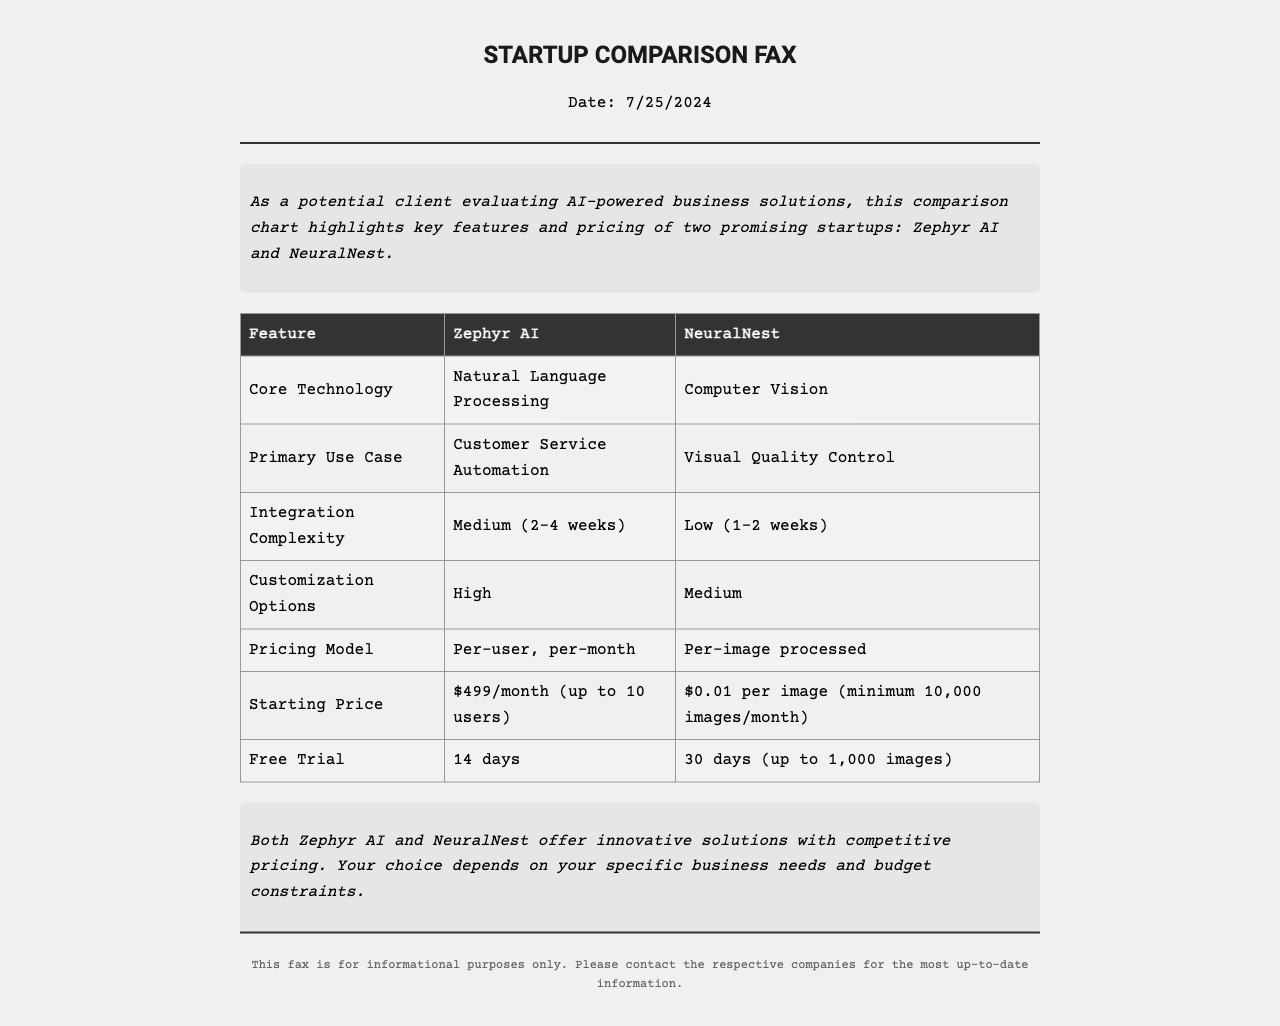What is the core technology used by Zephyr AI? The document states that the core technology for Zephyr AI is Natural Language Processing.
Answer: Natural Language Processing What is the primary use case for NeuralNest? According to the document, the primary use case for NeuralNest is Visual Quality Control.
Answer: Visual Quality Control What is the starting price for Zephyr AI? The starting price for Zephyr AI, as specified in the document, is $499 per month for up to 10 users.
Answer: $499/month (up to 10 users) How long is NeuralNest's free trial? The document indicates that NeuralNest offers a free trial period of 30 days.
Answer: 30 days Which startup has a higher customization option? The comparison in the document shows that Zephyr AI has High customization options, while NeuralNest has Medium customization options.
Answer: Zephyr AI What is the integration complexity of Zephyr AI? The document specifies that the integration complexity for Zephyr AI is Medium, taking about 2-4 weeks.
Answer: Medium (2-4 weeks) What pricing model does NeuralNest use? The document states that NeuralNest uses a per-image processed pricing model.
Answer: Per-image processed Which startup has a longer free trial? The document reveals that NeuralNest offers a longer free trial compared to Zephyr AI.
Answer: NeuralNest What type of document is this? This document is identified as a comparison fax highlighting the offerings of two startups.
Answer: Comparison fax 